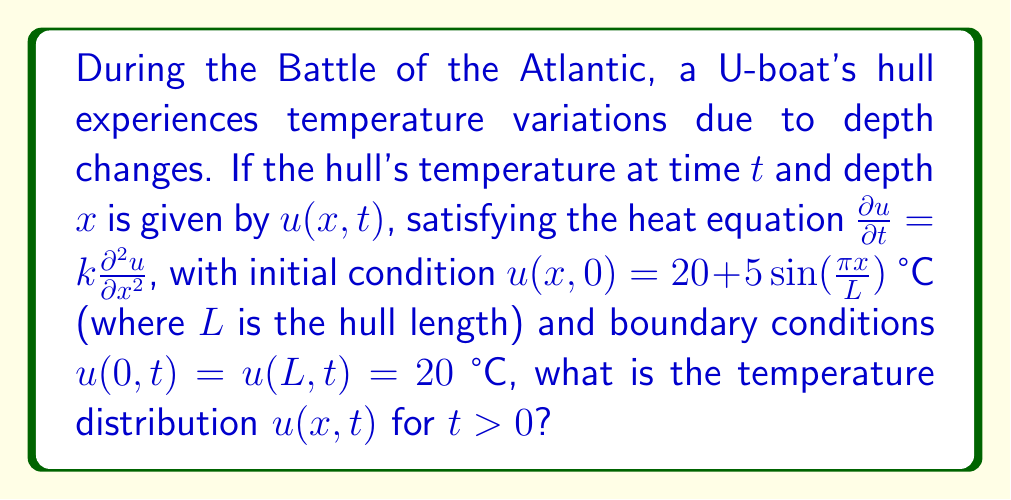Can you answer this question? To solve this heat equation problem for the U-boat hull, we'll follow these steps:

1) The heat equation is given by:
   $$\frac{\partial u}{\partial t} = k\frac{\partial^2 u}{\partial x^2}$$

2) We have the following conditions:
   Initial condition: $u(x,0) = 20 + 5\sin(\frac{\pi x}{L})$
   Boundary conditions: $u(0,t) = u(L,t) = 20$

3) The solution can be found using separation of variables. Let $u(x,t) = X(x)T(t)$

4) Substituting into the heat equation:
   $$X(x)T'(t) = kX''(x)T(t)$$
   $$\frac{T'(t)}{kT(t)} = \frac{X''(x)}{X(x)} = -\lambda$$

5) This gives us two ordinary differential equations:
   $$T'(t) + k\lambda T(t) = 0$$
   $$X''(x) + \lambda X(x) = 0$$

6) The general solutions are:
   $$T(t) = Ae^{-k\lambda t}$$
   $$X(x) = B\sin(\sqrt{\lambda}x) + C\cos(\sqrt{\lambda}x)$$

7) Applying the boundary conditions:
   $X(0) = 0$ implies $C = 0$
   $X(L) = 0$ implies $\sin(\sqrt{\lambda}L) = 0$, so $\sqrt{\lambda}L = n\pi$, or $\lambda = (\frac{n\pi}{L})^2$

8) Therefore, the general solution is:
   $$u(x,t) = \sum_{n=1}^{\infty} A_n \sin(\frac{n\pi x}{L})e^{-k(\frac{n\pi}{L})^2t}$$

9) To find $A_n$, we use the initial condition:
   $$20 + 5\sin(\frac{\pi x}{L}) = \sum_{n=1}^{\infty} A_n \sin(\frac{n\pi x}{L})$$

10) This implies $A_1 = 5$ and $A_n = 0$ for $n > 1$

11) The final solution is:
    $$u(x,t) = 20 + 5\sin(\frac{\pi x}{L})e^{-k(\frac{\pi}{L})^2t}$$

This solution represents the temperature distribution in the U-boat hull over time and depth.
Answer: $u(x,t) = 20 + 5\sin(\frac{\pi x}{L})e^{-k(\frac{\pi}{L})^2t}$ 